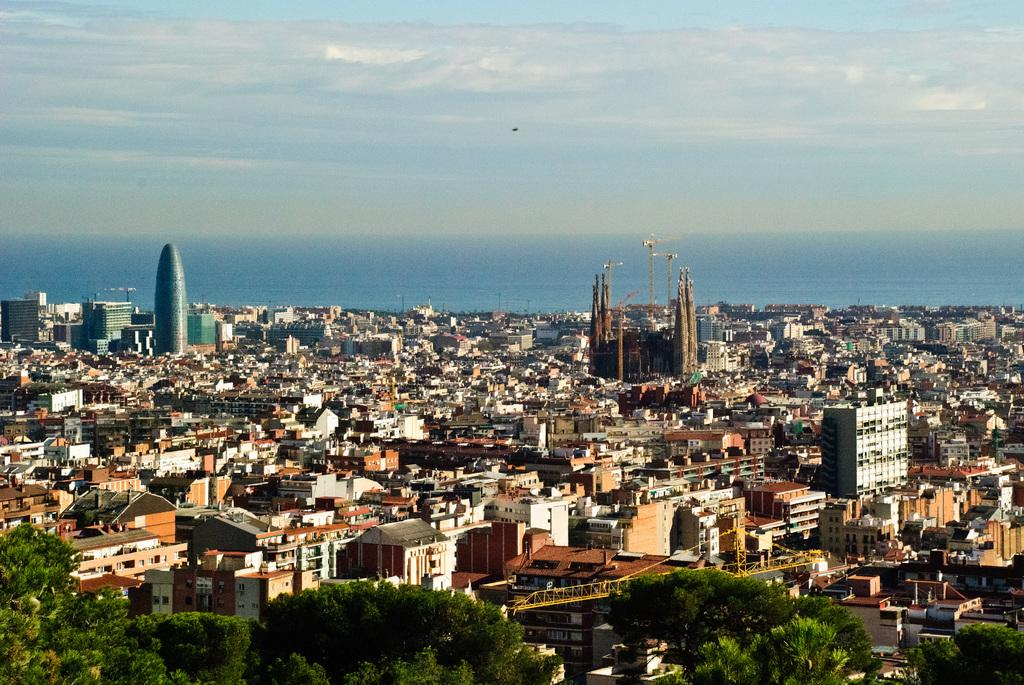What type of structures can be seen in the image? There are buildings in the image. What natural elements are present in the image? There are trees in the image. What type of machinery is visible in the image? There is a crane in the image. How would you describe the sky in the image? The sky is blue and cloudy in the image. What type of tramp can be seen jumping near the crane in the image? There is no tramp present in the image; it only features buildings, trees, a crane, and a blue and cloudy sky. What type of hook is attached to the crane in the image? The image does not show any hooks attached to the crane; it only shows the crane itself. 